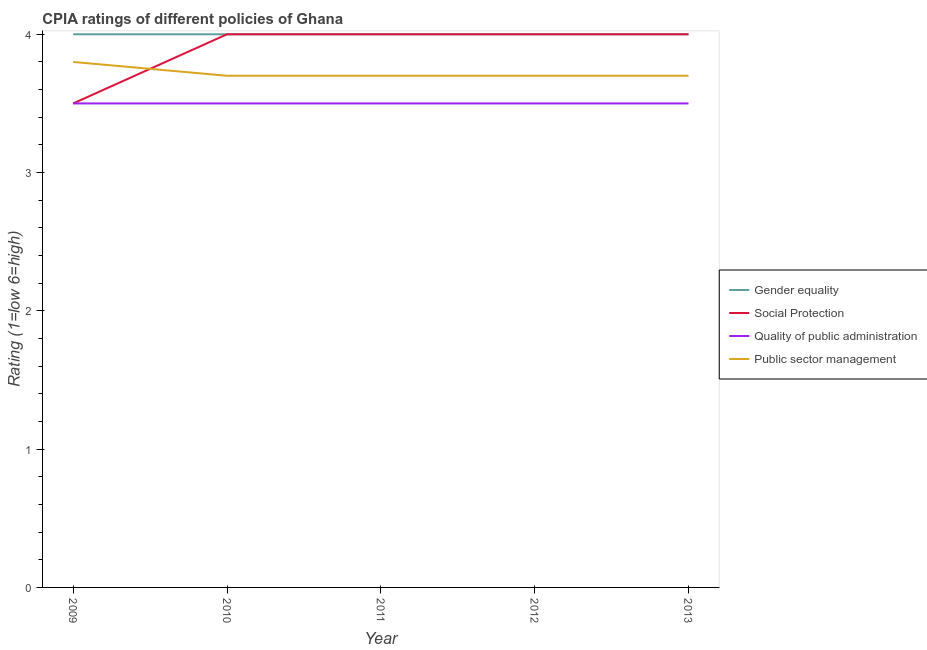How many different coloured lines are there?
Provide a succinct answer. 4. Is the number of lines equal to the number of legend labels?
Your answer should be very brief. Yes. What is the cpia rating of gender equality in 2010?
Provide a short and direct response. 4. Across all years, what is the minimum cpia rating of gender equality?
Keep it short and to the point. 4. In which year was the cpia rating of gender equality minimum?
Your answer should be compact. 2009. What is the total cpia rating of public sector management in the graph?
Give a very brief answer. 18.6. What is the difference between the cpia rating of public sector management in 2011 and the cpia rating of social protection in 2013?
Offer a very short reply. -0.3. In how many years, is the cpia rating of public sector management greater than 3.4?
Give a very brief answer. 5. Is the cpia rating of public sector management in 2010 less than that in 2013?
Your answer should be very brief. No. What is the difference between the highest and the lowest cpia rating of quality of public administration?
Your response must be concise. 0. In how many years, is the cpia rating of social protection greater than the average cpia rating of social protection taken over all years?
Give a very brief answer. 4. Is it the case that in every year, the sum of the cpia rating of public sector management and cpia rating of gender equality is greater than the sum of cpia rating of quality of public administration and cpia rating of social protection?
Provide a succinct answer. Yes. Is it the case that in every year, the sum of the cpia rating of gender equality and cpia rating of social protection is greater than the cpia rating of quality of public administration?
Your answer should be compact. Yes. Is the cpia rating of quality of public administration strictly greater than the cpia rating of public sector management over the years?
Your response must be concise. No. Does the graph contain any zero values?
Your answer should be very brief. No. Does the graph contain grids?
Provide a short and direct response. No. How many legend labels are there?
Your answer should be compact. 4. How are the legend labels stacked?
Your answer should be very brief. Vertical. What is the title of the graph?
Keep it short and to the point. CPIA ratings of different policies of Ghana. What is the Rating (1=low 6=high) in Gender equality in 2009?
Your answer should be compact. 4. What is the Rating (1=low 6=high) of Social Protection in 2009?
Your answer should be very brief. 3.5. What is the Rating (1=low 6=high) in Quality of public administration in 2009?
Your answer should be compact. 3.5. What is the Rating (1=low 6=high) in Public sector management in 2009?
Provide a succinct answer. 3.8. What is the Rating (1=low 6=high) of Gender equality in 2010?
Provide a short and direct response. 4. What is the Rating (1=low 6=high) of Public sector management in 2010?
Offer a terse response. 3.7. What is the Rating (1=low 6=high) of Gender equality in 2012?
Your answer should be compact. 4. What is the Rating (1=low 6=high) in Quality of public administration in 2012?
Make the answer very short. 3.5. What is the Rating (1=low 6=high) in Public sector management in 2012?
Provide a short and direct response. 3.7. What is the Rating (1=low 6=high) in Gender equality in 2013?
Your answer should be compact. 4. What is the Rating (1=low 6=high) of Quality of public administration in 2013?
Ensure brevity in your answer.  3.5. What is the Rating (1=low 6=high) in Public sector management in 2013?
Keep it short and to the point. 3.7. Across all years, what is the maximum Rating (1=low 6=high) in Gender equality?
Keep it short and to the point. 4. Across all years, what is the maximum Rating (1=low 6=high) in Quality of public administration?
Your response must be concise. 3.5. Across all years, what is the maximum Rating (1=low 6=high) of Public sector management?
Offer a very short reply. 3.8. Across all years, what is the minimum Rating (1=low 6=high) in Gender equality?
Give a very brief answer. 4. Across all years, what is the minimum Rating (1=low 6=high) of Public sector management?
Your answer should be compact. 3.7. What is the total Rating (1=low 6=high) of Public sector management in the graph?
Offer a terse response. 18.6. What is the difference between the Rating (1=low 6=high) of Gender equality in 2009 and that in 2010?
Your response must be concise. 0. What is the difference between the Rating (1=low 6=high) in Gender equality in 2009 and that in 2011?
Your response must be concise. 0. What is the difference between the Rating (1=low 6=high) in Social Protection in 2009 and that in 2011?
Your response must be concise. -0.5. What is the difference between the Rating (1=low 6=high) of Public sector management in 2009 and that in 2011?
Keep it short and to the point. 0.1. What is the difference between the Rating (1=low 6=high) in Social Protection in 2009 and that in 2012?
Provide a succinct answer. -0.5. What is the difference between the Rating (1=low 6=high) of Quality of public administration in 2009 and that in 2012?
Provide a succinct answer. 0. What is the difference between the Rating (1=low 6=high) of Public sector management in 2009 and that in 2012?
Your response must be concise. 0.1. What is the difference between the Rating (1=low 6=high) in Gender equality in 2009 and that in 2013?
Ensure brevity in your answer.  0. What is the difference between the Rating (1=low 6=high) in Social Protection in 2009 and that in 2013?
Provide a short and direct response. -0.5. What is the difference between the Rating (1=low 6=high) of Quality of public administration in 2009 and that in 2013?
Offer a very short reply. 0. What is the difference between the Rating (1=low 6=high) in Public sector management in 2009 and that in 2013?
Provide a succinct answer. 0.1. What is the difference between the Rating (1=low 6=high) of Social Protection in 2010 and that in 2011?
Offer a very short reply. 0. What is the difference between the Rating (1=low 6=high) in Public sector management in 2010 and that in 2011?
Your response must be concise. 0. What is the difference between the Rating (1=low 6=high) of Gender equality in 2010 and that in 2012?
Provide a short and direct response. 0. What is the difference between the Rating (1=low 6=high) of Social Protection in 2010 and that in 2012?
Offer a terse response. 0. What is the difference between the Rating (1=low 6=high) of Quality of public administration in 2010 and that in 2012?
Offer a terse response. 0. What is the difference between the Rating (1=low 6=high) of Gender equality in 2010 and that in 2013?
Your answer should be very brief. 0. What is the difference between the Rating (1=low 6=high) of Social Protection in 2010 and that in 2013?
Keep it short and to the point. 0. What is the difference between the Rating (1=low 6=high) in Social Protection in 2011 and that in 2012?
Offer a very short reply. 0. What is the difference between the Rating (1=low 6=high) of Quality of public administration in 2011 and that in 2012?
Ensure brevity in your answer.  0. What is the difference between the Rating (1=low 6=high) in Gender equality in 2011 and that in 2013?
Keep it short and to the point. 0. What is the difference between the Rating (1=low 6=high) of Social Protection in 2011 and that in 2013?
Offer a terse response. 0. What is the difference between the Rating (1=low 6=high) of Public sector management in 2011 and that in 2013?
Your response must be concise. 0. What is the difference between the Rating (1=low 6=high) in Gender equality in 2012 and that in 2013?
Provide a succinct answer. 0. What is the difference between the Rating (1=low 6=high) of Social Protection in 2012 and that in 2013?
Your answer should be compact. 0. What is the difference between the Rating (1=low 6=high) of Public sector management in 2012 and that in 2013?
Make the answer very short. 0. What is the difference between the Rating (1=low 6=high) in Gender equality in 2009 and the Rating (1=low 6=high) in Social Protection in 2010?
Your response must be concise. 0. What is the difference between the Rating (1=low 6=high) of Gender equality in 2009 and the Rating (1=low 6=high) of Quality of public administration in 2010?
Offer a very short reply. 0.5. What is the difference between the Rating (1=low 6=high) of Social Protection in 2009 and the Rating (1=low 6=high) of Public sector management in 2010?
Ensure brevity in your answer.  -0.2. What is the difference between the Rating (1=low 6=high) in Gender equality in 2009 and the Rating (1=low 6=high) in Quality of public administration in 2011?
Keep it short and to the point. 0.5. What is the difference between the Rating (1=low 6=high) of Gender equality in 2009 and the Rating (1=low 6=high) of Public sector management in 2011?
Give a very brief answer. 0.3. What is the difference between the Rating (1=low 6=high) in Gender equality in 2009 and the Rating (1=low 6=high) in Public sector management in 2012?
Your answer should be compact. 0.3. What is the difference between the Rating (1=low 6=high) of Social Protection in 2009 and the Rating (1=low 6=high) of Quality of public administration in 2012?
Offer a terse response. 0. What is the difference between the Rating (1=low 6=high) in Quality of public administration in 2009 and the Rating (1=low 6=high) in Public sector management in 2012?
Offer a terse response. -0.2. What is the difference between the Rating (1=low 6=high) in Social Protection in 2009 and the Rating (1=low 6=high) in Quality of public administration in 2013?
Your answer should be compact. 0. What is the difference between the Rating (1=low 6=high) in Quality of public administration in 2009 and the Rating (1=low 6=high) in Public sector management in 2013?
Your answer should be very brief. -0.2. What is the difference between the Rating (1=low 6=high) in Social Protection in 2010 and the Rating (1=low 6=high) in Public sector management in 2011?
Offer a terse response. 0.3. What is the difference between the Rating (1=low 6=high) of Quality of public administration in 2010 and the Rating (1=low 6=high) of Public sector management in 2011?
Offer a terse response. -0.2. What is the difference between the Rating (1=low 6=high) of Social Protection in 2010 and the Rating (1=low 6=high) of Public sector management in 2012?
Make the answer very short. 0.3. What is the difference between the Rating (1=low 6=high) in Social Protection in 2010 and the Rating (1=low 6=high) in Quality of public administration in 2013?
Keep it short and to the point. 0.5. What is the difference between the Rating (1=low 6=high) of Social Protection in 2010 and the Rating (1=low 6=high) of Public sector management in 2013?
Ensure brevity in your answer.  0.3. What is the difference between the Rating (1=low 6=high) of Gender equality in 2011 and the Rating (1=low 6=high) of Social Protection in 2012?
Provide a succinct answer. 0. What is the difference between the Rating (1=low 6=high) of Gender equality in 2011 and the Rating (1=low 6=high) of Quality of public administration in 2012?
Give a very brief answer. 0.5. What is the difference between the Rating (1=low 6=high) in Gender equality in 2011 and the Rating (1=low 6=high) in Public sector management in 2012?
Ensure brevity in your answer.  0.3. What is the difference between the Rating (1=low 6=high) in Social Protection in 2011 and the Rating (1=low 6=high) in Public sector management in 2012?
Provide a short and direct response. 0.3. What is the difference between the Rating (1=low 6=high) in Quality of public administration in 2011 and the Rating (1=low 6=high) in Public sector management in 2012?
Offer a very short reply. -0.2. What is the difference between the Rating (1=low 6=high) of Gender equality in 2011 and the Rating (1=low 6=high) of Social Protection in 2013?
Ensure brevity in your answer.  0. What is the difference between the Rating (1=low 6=high) in Gender equality in 2011 and the Rating (1=low 6=high) in Quality of public administration in 2013?
Provide a short and direct response. 0.5. What is the difference between the Rating (1=low 6=high) in Social Protection in 2011 and the Rating (1=low 6=high) in Quality of public administration in 2013?
Your answer should be compact. 0.5. What is the difference between the Rating (1=low 6=high) in Gender equality in 2012 and the Rating (1=low 6=high) in Social Protection in 2013?
Your response must be concise. 0. What is the difference between the Rating (1=low 6=high) in Gender equality in 2012 and the Rating (1=low 6=high) in Quality of public administration in 2013?
Provide a succinct answer. 0.5. What is the difference between the Rating (1=low 6=high) in Social Protection in 2012 and the Rating (1=low 6=high) in Quality of public administration in 2013?
Ensure brevity in your answer.  0.5. What is the difference between the Rating (1=low 6=high) in Social Protection in 2012 and the Rating (1=low 6=high) in Public sector management in 2013?
Make the answer very short. 0.3. What is the difference between the Rating (1=low 6=high) in Quality of public administration in 2012 and the Rating (1=low 6=high) in Public sector management in 2013?
Your response must be concise. -0.2. What is the average Rating (1=low 6=high) of Social Protection per year?
Offer a very short reply. 3.9. What is the average Rating (1=low 6=high) in Public sector management per year?
Keep it short and to the point. 3.72. In the year 2009, what is the difference between the Rating (1=low 6=high) in Gender equality and Rating (1=low 6=high) in Social Protection?
Ensure brevity in your answer.  0.5. In the year 2009, what is the difference between the Rating (1=low 6=high) in Gender equality and Rating (1=low 6=high) in Quality of public administration?
Your answer should be compact. 0.5. In the year 2009, what is the difference between the Rating (1=low 6=high) in Gender equality and Rating (1=low 6=high) in Public sector management?
Keep it short and to the point. 0.2. In the year 2010, what is the difference between the Rating (1=low 6=high) in Gender equality and Rating (1=low 6=high) in Quality of public administration?
Provide a short and direct response. 0.5. In the year 2010, what is the difference between the Rating (1=low 6=high) of Gender equality and Rating (1=low 6=high) of Public sector management?
Your answer should be very brief. 0.3. In the year 2011, what is the difference between the Rating (1=low 6=high) in Gender equality and Rating (1=low 6=high) in Social Protection?
Keep it short and to the point. 0. In the year 2011, what is the difference between the Rating (1=low 6=high) of Gender equality and Rating (1=low 6=high) of Quality of public administration?
Offer a terse response. 0.5. In the year 2011, what is the difference between the Rating (1=low 6=high) of Gender equality and Rating (1=low 6=high) of Public sector management?
Provide a succinct answer. 0.3. In the year 2011, what is the difference between the Rating (1=low 6=high) of Social Protection and Rating (1=low 6=high) of Public sector management?
Offer a very short reply. 0.3. In the year 2011, what is the difference between the Rating (1=low 6=high) of Quality of public administration and Rating (1=low 6=high) of Public sector management?
Ensure brevity in your answer.  -0.2. In the year 2012, what is the difference between the Rating (1=low 6=high) in Gender equality and Rating (1=low 6=high) in Social Protection?
Keep it short and to the point. 0. In the year 2012, what is the difference between the Rating (1=low 6=high) of Gender equality and Rating (1=low 6=high) of Quality of public administration?
Provide a short and direct response. 0.5. In the year 2012, what is the difference between the Rating (1=low 6=high) in Gender equality and Rating (1=low 6=high) in Public sector management?
Ensure brevity in your answer.  0.3. In the year 2012, what is the difference between the Rating (1=low 6=high) in Social Protection and Rating (1=low 6=high) in Quality of public administration?
Ensure brevity in your answer.  0.5. In the year 2013, what is the difference between the Rating (1=low 6=high) of Gender equality and Rating (1=low 6=high) of Quality of public administration?
Your response must be concise. 0.5. In the year 2013, what is the difference between the Rating (1=low 6=high) in Gender equality and Rating (1=low 6=high) in Public sector management?
Make the answer very short. 0.3. In the year 2013, what is the difference between the Rating (1=low 6=high) of Social Protection and Rating (1=low 6=high) of Quality of public administration?
Offer a very short reply. 0.5. What is the ratio of the Rating (1=low 6=high) in Gender equality in 2009 to that in 2010?
Provide a succinct answer. 1. What is the ratio of the Rating (1=low 6=high) of Public sector management in 2009 to that in 2010?
Offer a very short reply. 1.03. What is the ratio of the Rating (1=low 6=high) of Social Protection in 2009 to that in 2011?
Your answer should be compact. 0.88. What is the ratio of the Rating (1=low 6=high) of Quality of public administration in 2009 to that in 2011?
Your response must be concise. 1. What is the ratio of the Rating (1=low 6=high) of Public sector management in 2009 to that in 2011?
Your answer should be very brief. 1.03. What is the ratio of the Rating (1=low 6=high) in Quality of public administration in 2009 to that in 2012?
Offer a terse response. 1. What is the ratio of the Rating (1=low 6=high) of Social Protection in 2009 to that in 2013?
Your response must be concise. 0.88. What is the ratio of the Rating (1=low 6=high) of Quality of public administration in 2009 to that in 2013?
Your answer should be compact. 1. What is the ratio of the Rating (1=low 6=high) of Public sector management in 2009 to that in 2013?
Keep it short and to the point. 1.03. What is the ratio of the Rating (1=low 6=high) in Gender equality in 2010 to that in 2011?
Your response must be concise. 1. What is the ratio of the Rating (1=low 6=high) in Quality of public administration in 2010 to that in 2011?
Make the answer very short. 1. What is the ratio of the Rating (1=low 6=high) in Social Protection in 2010 to that in 2012?
Make the answer very short. 1. What is the ratio of the Rating (1=low 6=high) of Quality of public administration in 2010 to that in 2012?
Your response must be concise. 1. What is the ratio of the Rating (1=low 6=high) of Public sector management in 2010 to that in 2012?
Provide a succinct answer. 1. What is the ratio of the Rating (1=low 6=high) of Gender equality in 2011 to that in 2012?
Offer a very short reply. 1. What is the ratio of the Rating (1=low 6=high) of Quality of public administration in 2011 to that in 2012?
Make the answer very short. 1. What is the ratio of the Rating (1=low 6=high) in Public sector management in 2011 to that in 2012?
Make the answer very short. 1. What is the ratio of the Rating (1=low 6=high) of Gender equality in 2011 to that in 2013?
Make the answer very short. 1. What is the ratio of the Rating (1=low 6=high) in Quality of public administration in 2011 to that in 2013?
Keep it short and to the point. 1. What is the ratio of the Rating (1=low 6=high) of Social Protection in 2012 to that in 2013?
Offer a very short reply. 1. What is the difference between the highest and the second highest Rating (1=low 6=high) of Gender equality?
Keep it short and to the point. 0. What is the difference between the highest and the second highest Rating (1=low 6=high) of Quality of public administration?
Provide a short and direct response. 0. 